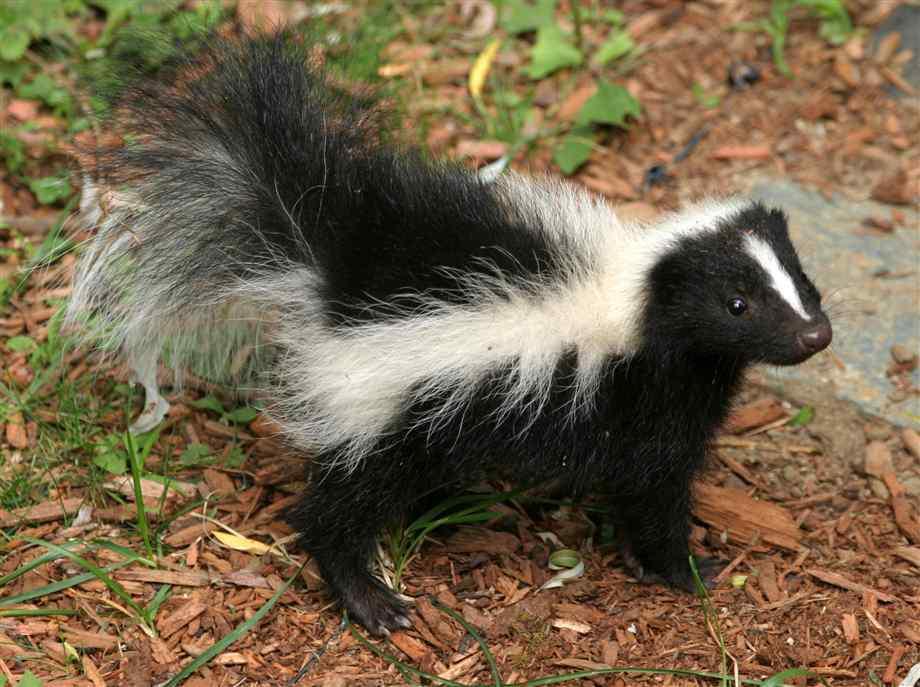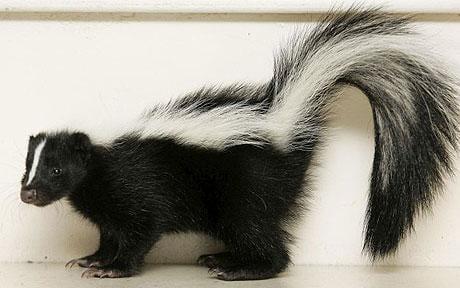The first image is the image on the left, the second image is the image on the right. For the images displayed, is the sentence "All skunks are standing with their bodies in profile and all skunks have their bodies turned in the same direction." factually correct? Answer yes or no. No. The first image is the image on the left, the second image is the image on the right. Analyze the images presented: Is the assertion "In the image to the left, the skunk is standing among some green grass." valid? Answer yes or no. Yes. 